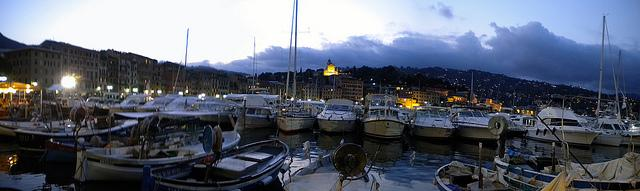What are the round objects on the boats used for? hoisting sails 